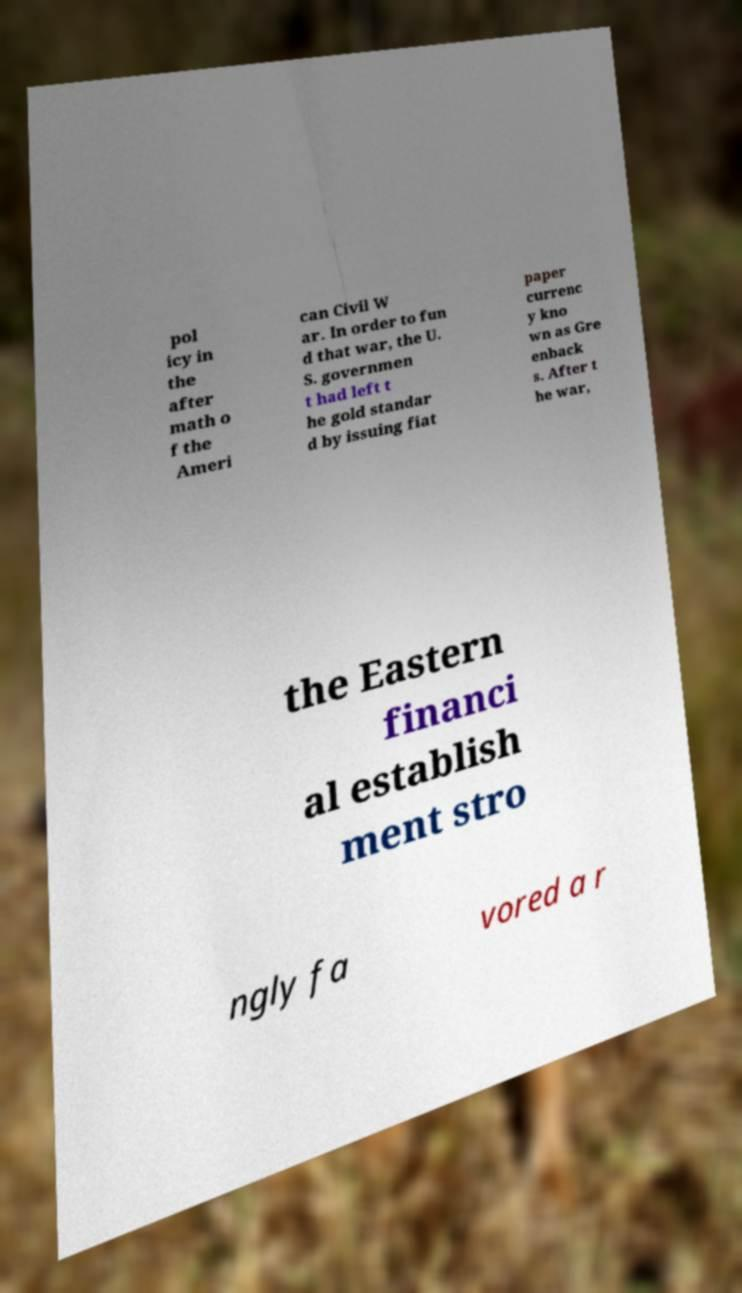Can you accurately transcribe the text from the provided image for me? pol icy in the after math o f the Ameri can Civil W ar. In order to fun d that war, the U. S. governmen t had left t he gold standar d by issuing fiat paper currenc y kno wn as Gre enback s. After t he war, the Eastern financi al establish ment stro ngly fa vored a r 